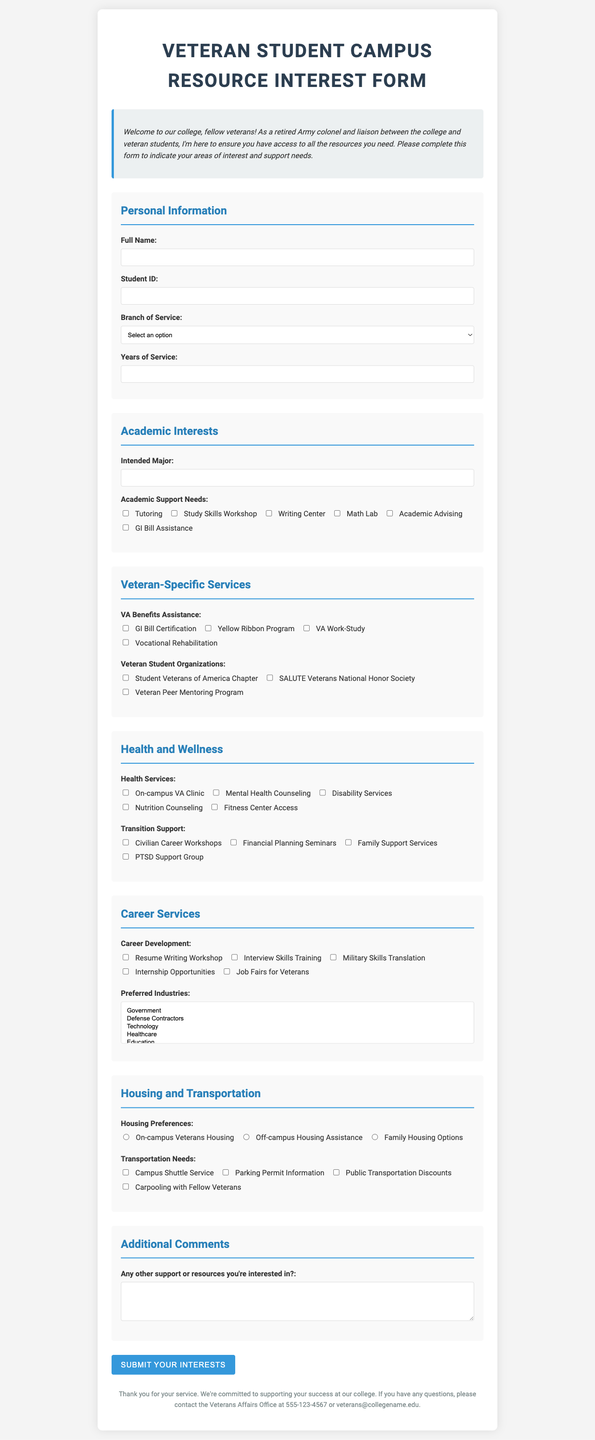what is the title of the form? The title of the form is located at the top of the document.
Answer: Veteran Student Campus Resource Interest Form how many branches of service are listed? The branches of service can be counted in the dropdown options provided in the personal information section.
Answer: 6 what support is available for academic needs? The academic support options are provided as checkboxes in the academic interests section.
Answer: Tutoring, Study Skills Workshop, Writing Center, Math Lab, Academic Advising, GI Bill Assistance which organization is mentioned for veteran students? The veteran student organizations can be found in the veteran-specific services section.
Answer: Student Veterans of America Chapter, SALUTE Veterans National Honor Society, Veteran Peer Mentoring Program what type of housing preferences is offered? The housing preferences can be found in the housing and transportation section as radio buttons.
Answer: On-campus Veterans Housing, Off-campus Housing Assistance, Family Housing Options what is the contact number for the Veterans Affairs Office? The contact information is listed in the footer of the document.
Answer: 555-123-4567 